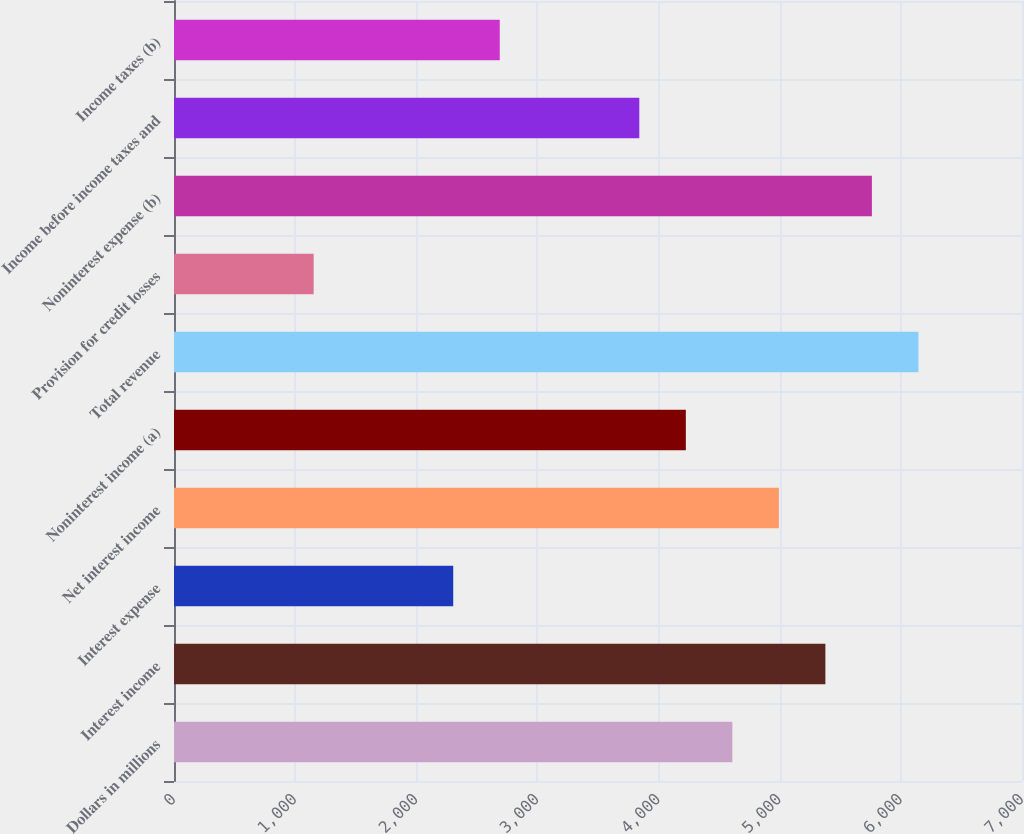Convert chart. <chart><loc_0><loc_0><loc_500><loc_500><bar_chart><fcel>Dollars in millions<fcel>Interest income<fcel>Interest expense<fcel>Net interest income<fcel>Noninterest income (a)<fcel>Total revenue<fcel>Provision for credit losses<fcel>Noninterest expense (b)<fcel>Income before income taxes and<fcel>Income taxes (b)<nl><fcel>4609<fcel>5377<fcel>2305<fcel>4993<fcel>4225<fcel>6145<fcel>1153<fcel>5761<fcel>3841<fcel>2689<nl></chart> 